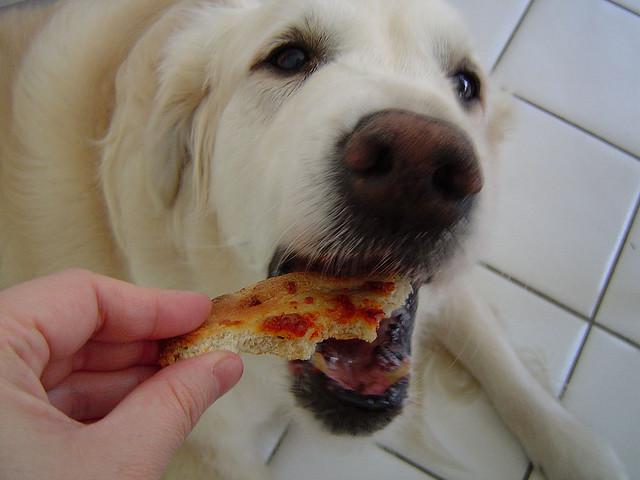What is the dog laying on?
Concise answer only. Floor. What feeling does the puppies face make you think of?
Be succinct. Hungry. What color is the dog?
Keep it brief. White. Is a barcode seen?
Concise answer only. No. What color is the nail polish on the woman's finger?
Quick response, please. Clear. What is the dog holding?
Be succinct. Pizza. Is this a short-haired dog?
Concise answer only. No. How many dogs are there?
Quick response, please. 1. What is keeping the puppy from going outside?
Be succinct. Door. What color are the dog's ears?
Concise answer only. White. How many fingers are in the picture?
Write a very short answer. 4. How many dogs are seen?
Keep it brief. 1. What is the dog eating?
Answer briefly. Pizza. Is this dog comfy?
Answer briefly. Yes. 